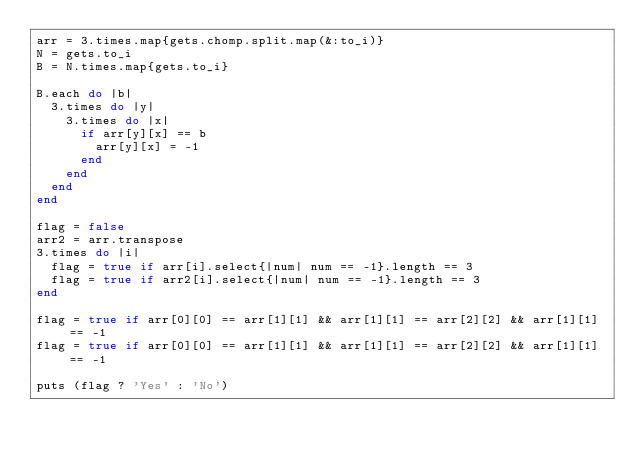<code> <loc_0><loc_0><loc_500><loc_500><_Ruby_>arr = 3.times.map{gets.chomp.split.map(&:to_i)}
N = gets.to_i
B = N.times.map{gets.to_i}

B.each do |b|
  3.times do |y|
    3.times do |x|
      if arr[y][x] == b
        arr[y][x] = -1
      end
    end
  end
end

flag = false
arr2 = arr.transpose
3.times do |i|
  flag = true if arr[i].select{|num| num == -1}.length == 3
  flag = true if arr2[i].select{|num| num == -1}.length == 3
end

flag = true if arr[0][0] == arr[1][1] && arr[1][1] == arr[2][2] && arr[1][1] == -1
flag = true if arr[0][0] == arr[1][1] && arr[1][1] == arr[2][2] && arr[1][1] == -1
  
puts (flag ? 'Yes' : 'No')
      </code> 